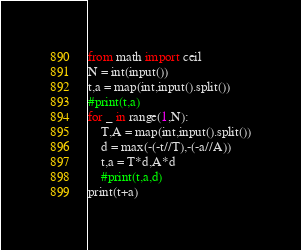<code> <loc_0><loc_0><loc_500><loc_500><_Python_>from math import ceil
N = int(input())
t,a = map(int,input().split())
#print(t,a)
for _ in range(1,N):
    T,A = map(int,input().split())
    d = max(-(-t//T),-(-a//A))
    t,a = T*d,A*d
    #print(t,a,d)
print(t+a)</code> 